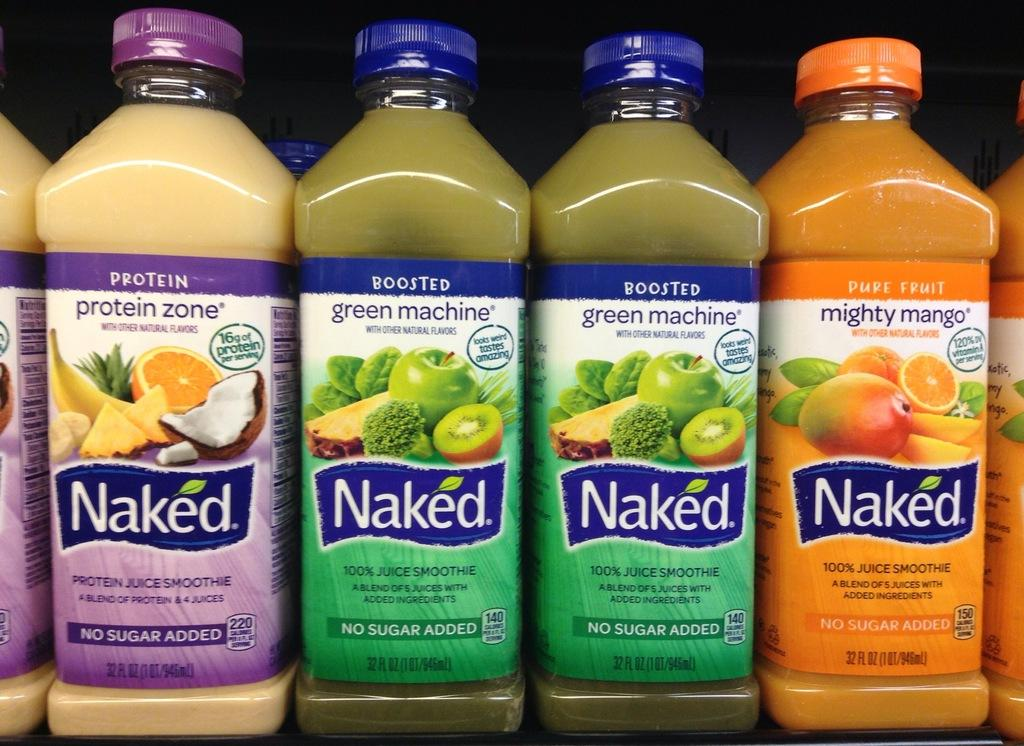What is the main subject of the image? The main subject of the image is a group of bottles. What distinguishes the bottles from one another? The bottles have different colored caps. Are there any additional decorations or markings on the bottles? Yes, there are stickers on the bottles. What type of dolls can be seen interacting with the loaf in the image? There are no dolls or loaf present in the image; it only features a group of bottles with different colored caps and stickers. 